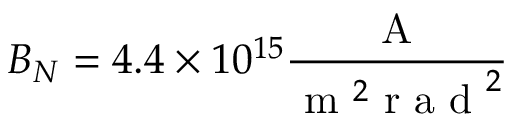Convert formula to latex. <formula><loc_0><loc_0><loc_500><loc_500>B _ { N } = 4 . 4 \times 1 0 ^ { 1 5 } \frac { A } { m ^ { 2 } r a d ^ { 2 } }</formula> 